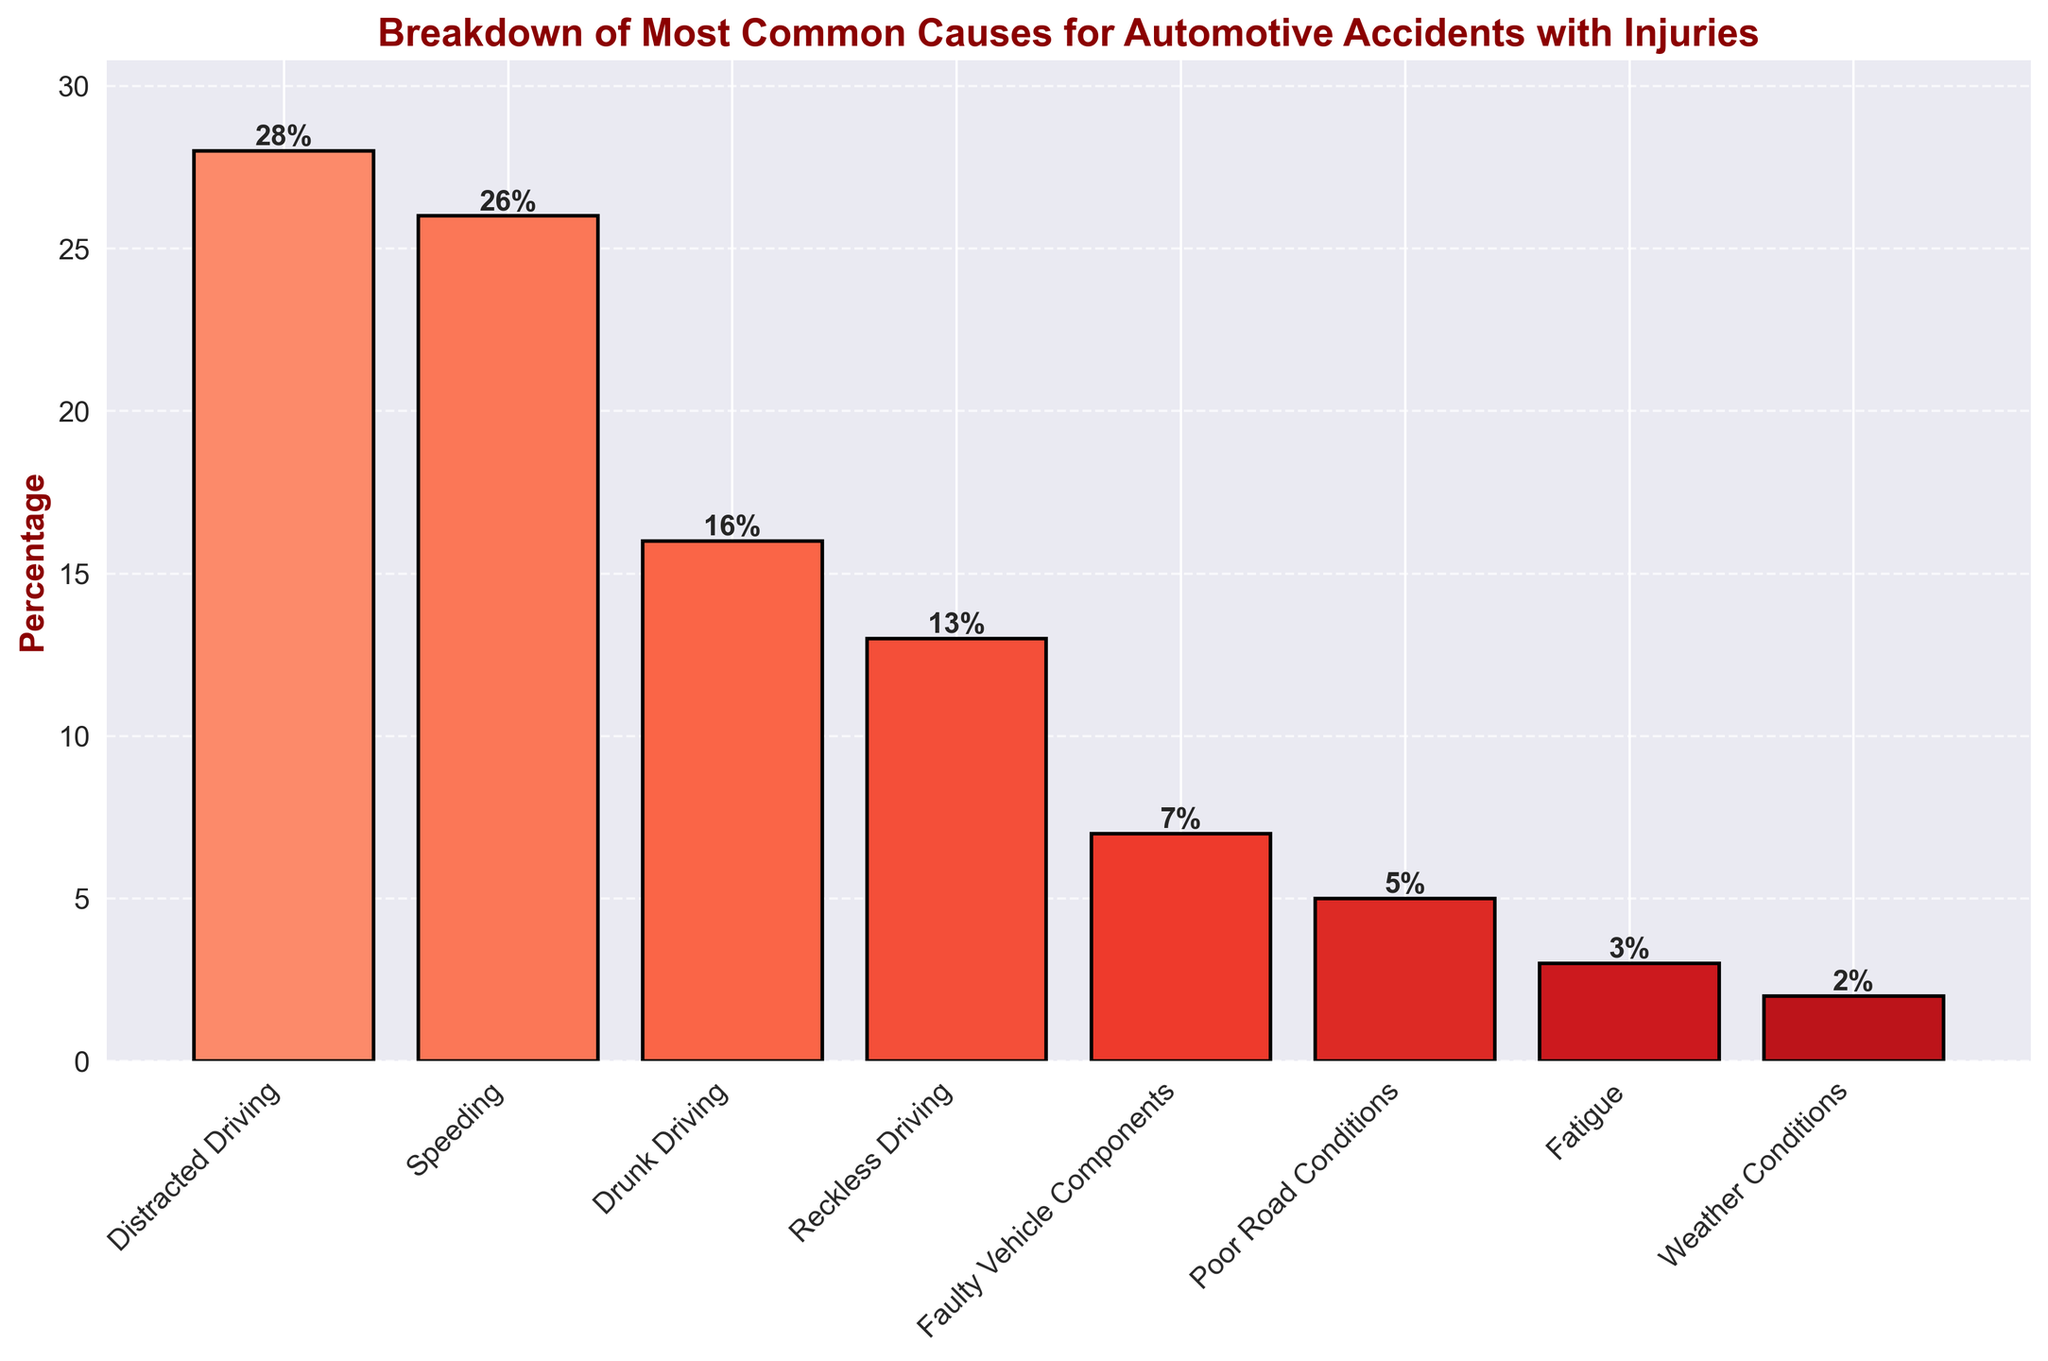What are the two most common causes for automotive accidents with injuries, and what are their respective percentages? The two most common causes for automotive accidents with injuries are Distracted Driving and Speeding. According to the chart, Distracted Driving accounts for 28% and Speeding accounts for 26% of accidents.
Answer: Distracted Driving (28%) and Speeding (26%) What is the combined percentage of accidents caused by Fatigue and Weather Conditions? To find the combined percentage, sum the individual percentages of Fatigue and Weather Conditions. Fatigue accounts for 3% and Weather Conditions account for 2%. The total is 3% + 2% = 5%.
Answer: 5% How much greater is the percentage of accidents caused by Drunk Driving compared to Faulty Vehicle Components? Drunk Driving accounts for 16% of accidents, while Faulty Vehicle Components account for 7%. Subtract 7 from 16 to get 16% - 7% = 9%.
Answer: 9% Which cause has a lower percentage: Poor Road Conditions or Fatigue? According to the chart, Poor Road Conditions account for 5% of accidents, and Fatigue accounts for 3%. Since 3% is lower than 5%, Fatigue has a lower percentage.
Answer: Fatigue By how much does the percentage of accidents due to Reckless Driving exceed those caused by Faulty Vehicle Components? Reckless Driving accounts for 13% of accidents while Faulty Vehicle Components account for 7%. Subtract 7 from 13 to get 13% - 7% = 6%.
Answer: 6% What is the percentage of accidents caused by the two least common causes combined? The two least common causes are Fatigue (3%) and Weather Conditions (2%). Their combined percentage is 3% + 2% = 5%.
Answer: 5% Compare the percentage of accidents caused by Speeding and Distracted Driving. Which is higher, and by how much? Speeding accounts for 26% of accidents, while Distracted Driving accounts for 28%. Distracted Driving is higher by 28% - 26% = 2%.
Answer: Distracted Driving by 2% What is the average percentage of accidents due to Reckless Driving, Faulty Vehicle Components, and Fatigue? To find the average, sum the percentages of Reckless Driving (13%), Faulty Vehicle Components (7%), and Fatigue (3%). The total is 13% + 7% + 3% = 23%. Divide by the number of causes (3) to get the average: 23% / 3 ≈ 7.67%.
Answer: 7.67% Which cause is depicted with the tallest bar, and what is its height? The tallest bar corresponds to the cause with the highest percentage, which is Distracted Driving. The height of this bar is 28%.
Answer: Distracted Driving (28%) What visual attribute differentiates the bars in the graph, and how is it distributed? The bars are differentiated by their height, which corresponds to the percentage of accidents each cause represents. The heights range from 2% to 28%, with higher percentages resulting in taller bars.
Answer: Height of the bars 